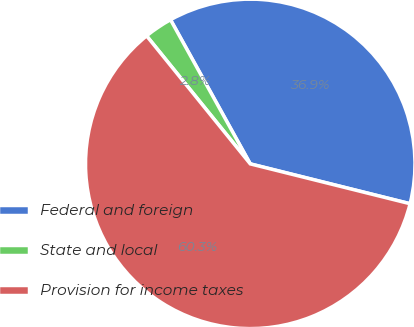Convert chart to OTSL. <chart><loc_0><loc_0><loc_500><loc_500><pie_chart><fcel>Federal and foreign<fcel>State and local<fcel>Provision for income taxes<nl><fcel>36.93%<fcel>2.79%<fcel>60.28%<nl></chart> 